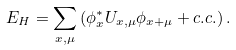<formula> <loc_0><loc_0><loc_500><loc_500>E _ { H } = \sum _ { x , \mu } \left ( \phi _ { x } ^ { * } U _ { x , \mu } \phi _ { x + \mu } + c . c . \right ) .</formula> 